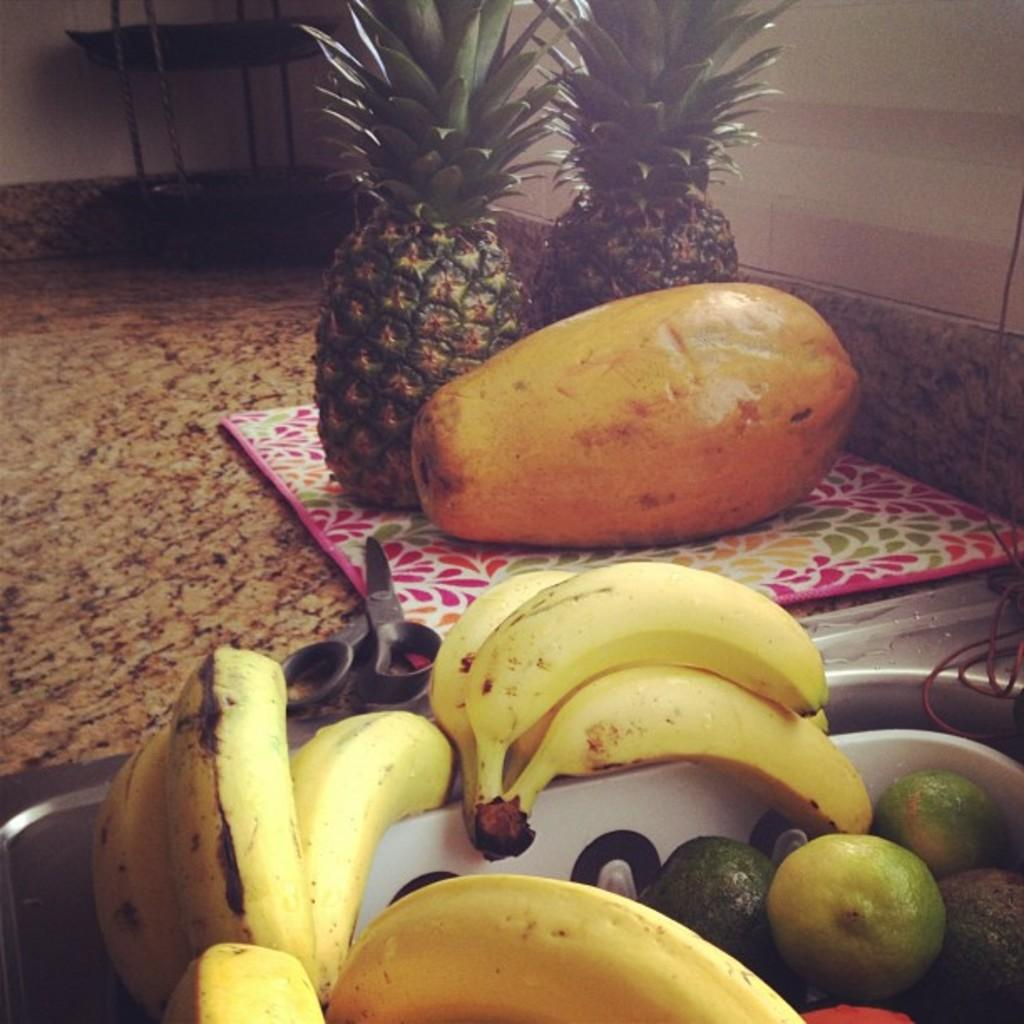What type of food items can be seen on the table in the image? There are fruits on the table in the image, including bananas, oranges, papayas, and pineapples. Can you name any specific fruits that are present on the table? Yes, bananas, oranges, papayas, and pineapples are present on the table. Are there any tools or utensils visible on the table? Yes, there are scissors on the table. What type of hat is being advertised on the table in the image? There is no hat or advertisement present in the image; it only features fruits and scissors on the table. Can you tell me the name of the ship that is docked near the table in the image? There is no ship visible in the image; it only features a table with fruits and scissors. 